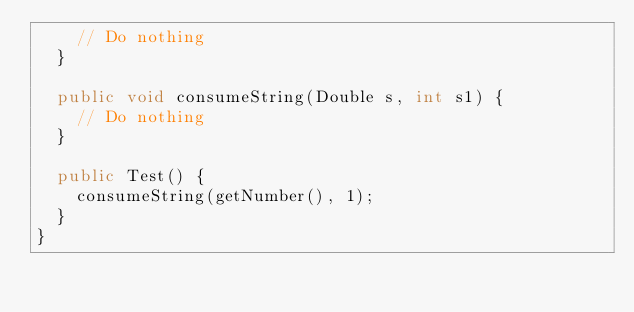<code> <loc_0><loc_0><loc_500><loc_500><_Java_>    // Do nothing
  }

  public void consumeString(Double s, int s1) {
    // Do nothing
  }

  public Test() {
    consumeString(getNumber(), 1);
  }
}
</code> 